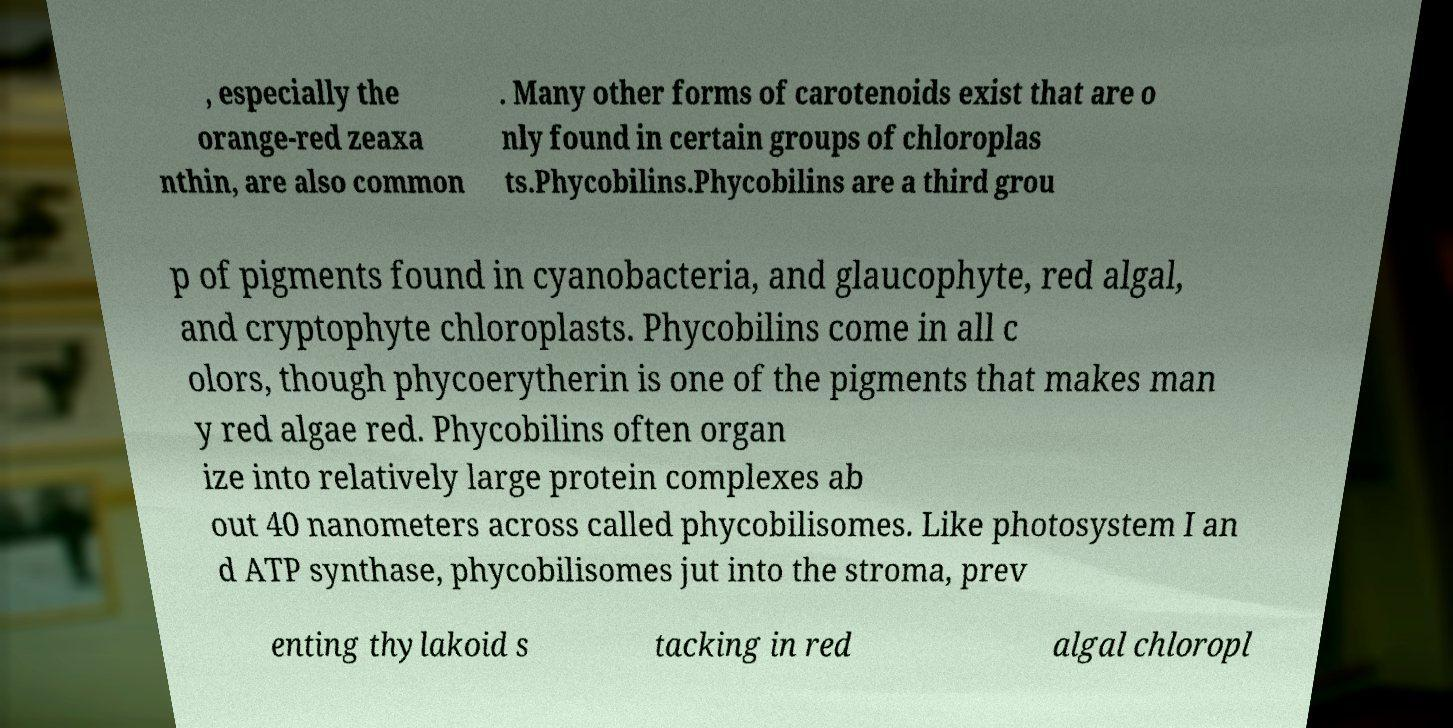Could you assist in decoding the text presented in this image and type it out clearly? , especially the orange-red zeaxa nthin, are also common . Many other forms of carotenoids exist that are o nly found in certain groups of chloroplas ts.Phycobilins.Phycobilins are a third grou p of pigments found in cyanobacteria, and glaucophyte, red algal, and cryptophyte chloroplasts. Phycobilins come in all c olors, though phycoerytherin is one of the pigments that makes man y red algae red. Phycobilins often organ ize into relatively large protein complexes ab out 40 nanometers across called phycobilisomes. Like photosystem I an d ATP synthase, phycobilisomes jut into the stroma, prev enting thylakoid s tacking in red algal chloropl 